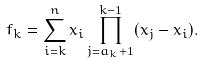Convert formula to latex. <formula><loc_0><loc_0><loc_500><loc_500>f _ { k } = \sum _ { i = k } ^ { n } x _ { i } \prod _ { j = a _ { k } + 1 } ^ { k - 1 } ( x _ { j } - x _ { i } ) .</formula> 